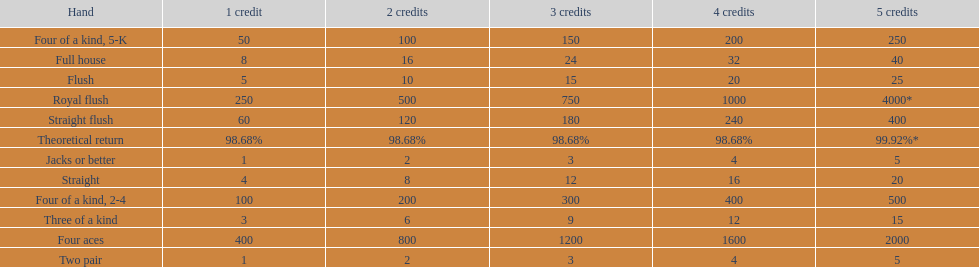Each four aces win is a multiple of what number? 400. 